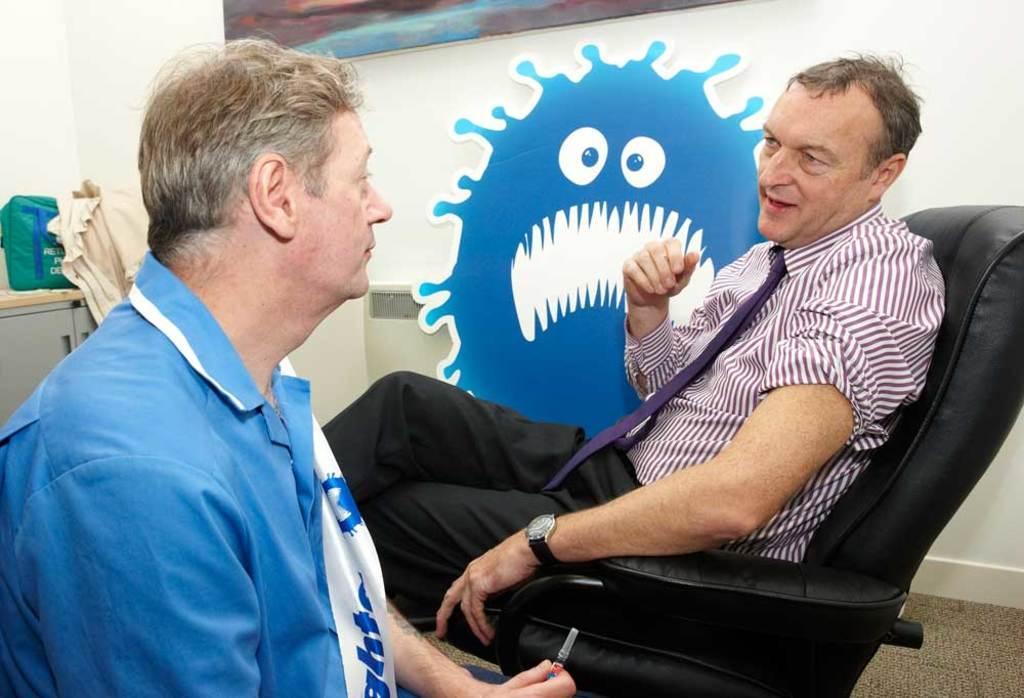Could you give a brief overview of what you see in this image? Two people are present in the picture where one man at the right corner is sitting on the sofa chair and wearing a tie and shirt and in front of him another person is sitting in a blue dress where a syringe in his hands and behind them there is one table on which one bag is present and there is one wall on which some cartoons on it. 